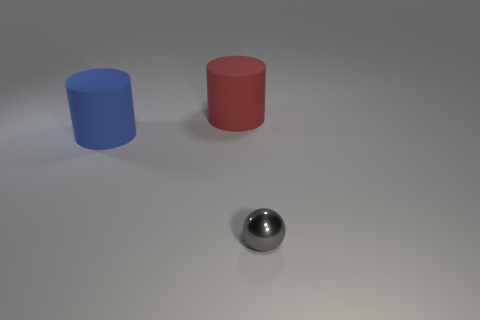There is a object that is left of the matte thing that is on the right side of the large rubber cylinder that is in front of the big red thing; what shape is it?
Provide a succinct answer. Cylinder. What shape is the thing that is in front of the red cylinder and behind the tiny sphere?
Offer a very short reply. Cylinder. There is a big cylinder that is left of the rubber cylinder that is right of the large blue thing; how many small gray balls are right of it?
Ensure brevity in your answer.  1. What is the size of the other rubber object that is the same shape as the big red rubber thing?
Your response must be concise. Large. Is there anything else that has the same size as the gray shiny sphere?
Offer a terse response. No. Does the blue cylinder that is in front of the large red matte cylinder have the same material as the ball?
Provide a short and direct response. No. There is another big rubber object that is the same shape as the blue matte thing; what color is it?
Your response must be concise. Red. Do the rubber object that is to the right of the big blue cylinder and the thing in front of the blue rubber object have the same shape?
Your answer should be compact. No. What number of cubes are big things or red matte things?
Offer a very short reply. 0. Is the number of large red matte cylinders in front of the large blue object less than the number of red shiny blocks?
Your response must be concise. No. 